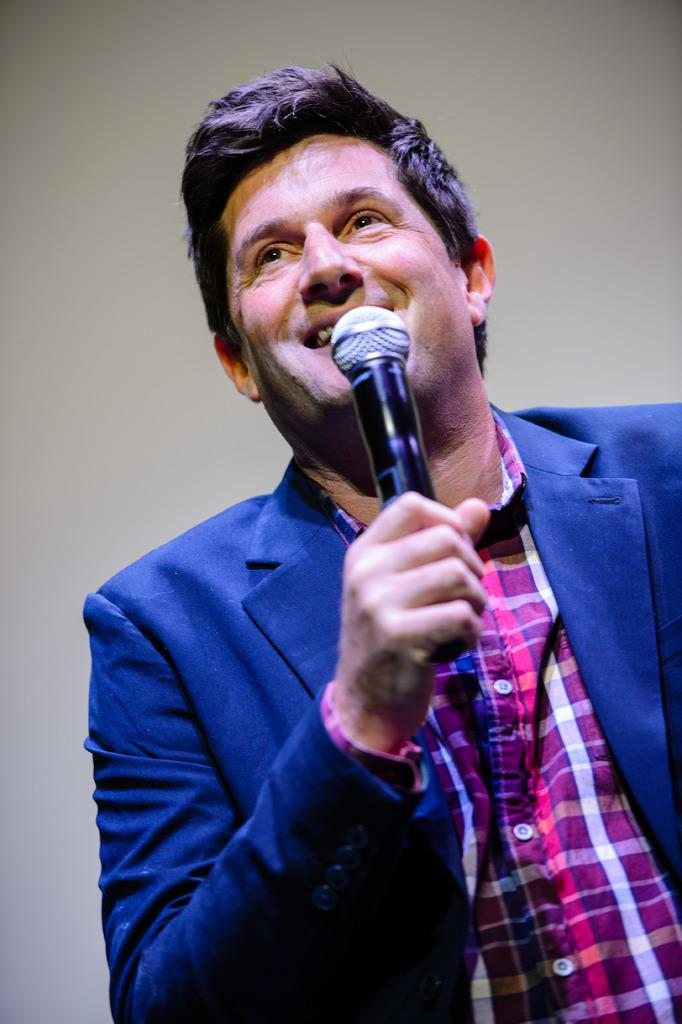What is the man in the image doing? The man is holding a microphone in the image. What is the man's facial expression in the image? The man is smiling in the image. What type of underwear is the man wearing in the image? There is no information about the man's underwear in the image, so it cannot be determined. 